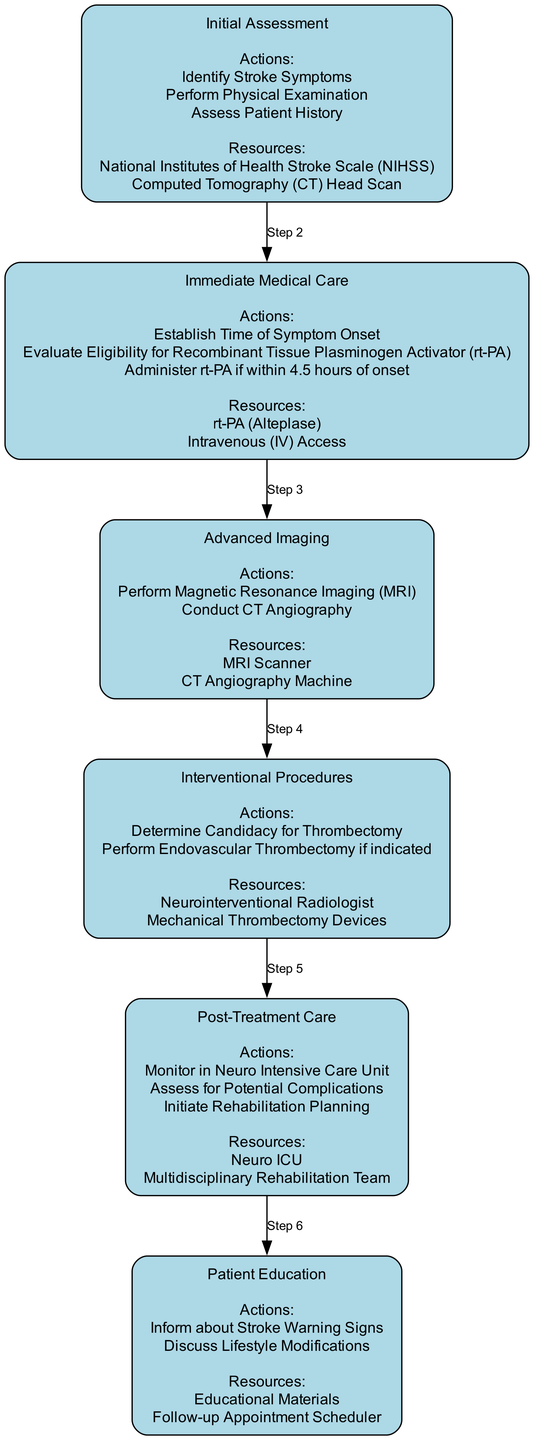What is the first step in the clinical pathway? The diagram lists "Initial Assessment" as the first step, indicating it is the starting point of the pathway for treating acute ischemic stroke.
Answer: Initial Assessment How many actions are listed in the "Immediate Medical Care" step? By examining the diagram, "Immediate Medical Care" includes three specific actions: establishing the time of symptom onset, evaluating eligibility for rt-PA, and administering rt-PA if applicable.
Answer: 3 What resource is used during the "Advanced Imaging" step? The "Advanced Imaging" step mentions two resources, among which "MRI Scanner" is one of the key pieces of equipment used for further evaluation of the patient.
Answer: MRI Scanner What follows the "Interventional Procedures" step? The diagram shows the flow from "Interventional Procedures" directly to "Post-Treatment Care," indicating that after intervention, the care of the patient shifts to this subsequent step.
Answer: Post-Treatment Care Which step involves monitoring in a specialized unit? The step "Post-Treatment Care" specifically mentions monitoring in the "Neuro Intensive Care Unit," where patients are closely observed for any complications after treatment.
Answer: Neuro Intensive Care Unit What is the last step listed in the diagram? Upon reviewing the diagram, the final step in the pathway is "Patient Education," which indicates a focus on informing patients and planning for their long-term health.
Answer: Patient Education How many total steps are present in the clinical pathway? Counting the steps in the diagram reveals a total of six distinct steps that outline the treatment protocol for acute ischemic stroke.
Answer: 6 What is the primary role of "Multidisciplinary Rehabilitation Team"? Within the "Post-Treatment Care" step, the "Multidisciplinary Rehabilitation Team" is responsible for initiating rehabilitation planning to help the patient recover after treatment.
Answer: Initiate Rehabilitation Planning What type of imaging is performed in the Advanced Imaging step? The "Advanced Imaging" step indicates that both Magnetic Resonance Imaging (MRI) and CT Angiography are performed as part of the diagnostic process.
Answer: Magnetic Resonance Imaging (MRI) and CT Angiography 